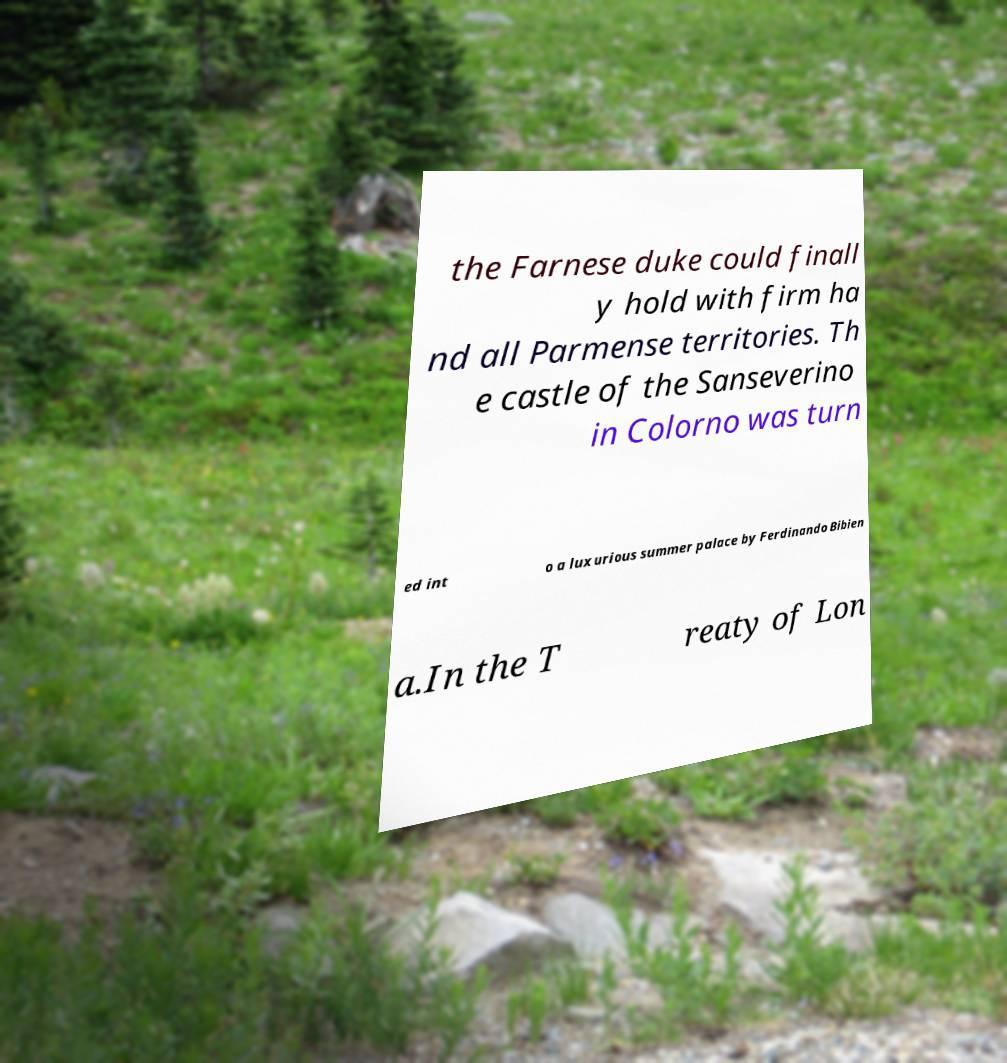I need the written content from this picture converted into text. Can you do that? the Farnese duke could finall y hold with firm ha nd all Parmense territories. Th e castle of the Sanseverino in Colorno was turn ed int o a luxurious summer palace by Ferdinando Bibien a.In the T reaty of Lon 